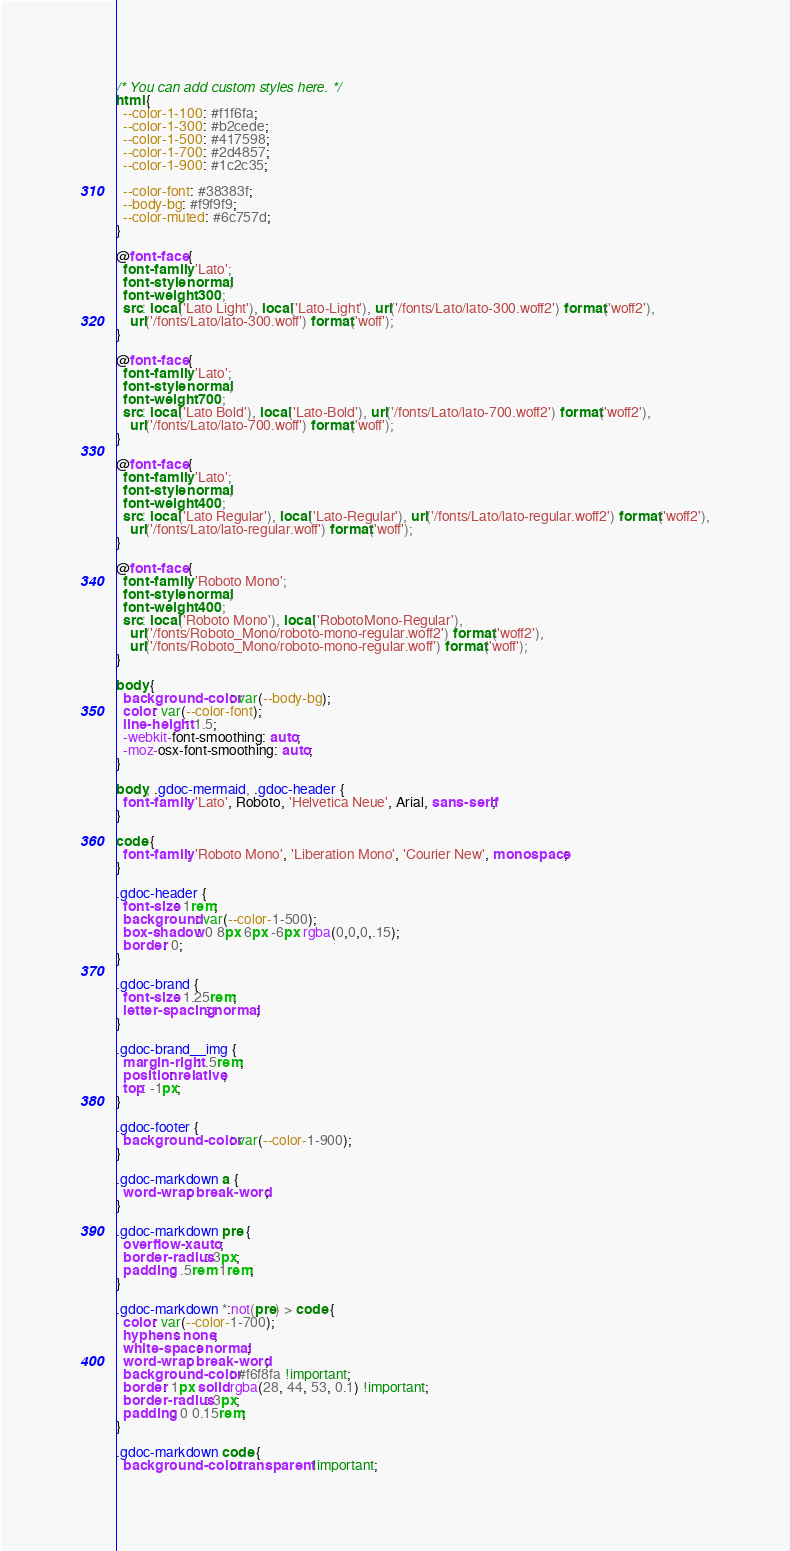Convert code to text. <code><loc_0><loc_0><loc_500><loc_500><_CSS_>/* You can add custom styles here. */
html {
  --color-1-100: #f1f6fa;
  --color-1-300: #b2cede;
  --color-1-500: #417598;
  --color-1-700: #2d4857;
  --color-1-900: #1c2c35;

  --color-font: #38383f;
  --body-bg: #f9f9f9;
  --color-muted: #6c757d;
}

@font-face {
  font-family: 'Lato';
  font-style: normal;
  font-weight: 300;
  src: local('Lato Light'), local('Lato-Light'), url('/fonts/Lato/lato-300.woff2') format('woff2'),
    url('/fonts/Lato/lato-300.woff') format('woff');
}

@font-face {
  font-family: 'Lato';
  font-style: normal;
  font-weight: 700;
  src: local('Lato Bold'), local('Lato-Bold'), url('/fonts/Lato/lato-700.woff2') format('woff2'),
    url('/fonts/Lato/lato-700.woff') format('woff');
}

@font-face {
  font-family: 'Lato';
  font-style: normal;
  font-weight: 400;
  src: local('Lato Regular'), local('Lato-Regular'), url('/fonts/Lato/lato-regular.woff2') format('woff2'),
    url('/fonts/Lato/lato-regular.woff') format('woff');
}

@font-face {
  font-family: 'Roboto Mono';
  font-style: normal;
  font-weight: 400;
  src: local('Roboto Mono'), local('RobotoMono-Regular'),
    url('/fonts/Roboto_Mono/roboto-mono-regular.woff2') format('woff2'),
    url('/fonts/Roboto_Mono/roboto-mono-regular.woff') format('woff');
}

body {
  background-color: var(--body-bg);
  color: var(--color-font);
  line-height: 1.5;
  -webkit-font-smoothing: auto;
  -moz-osx-font-smoothing: auto;
}

body, .gdoc-mermaid, .gdoc-header {
  font-family: 'Lato', Roboto, 'Helvetica Neue', Arial, sans-serif;
}

code {
  font-family: 'Roboto Mono', 'Liberation Mono', 'Courier New', monospace;
}

.gdoc-header {
  font-size: 1rem;
  background: var(--color-1-500);
  box-shadow: 0 8px 6px -6px rgba(0,0,0,.15);
  border: 0;
}

.gdoc-brand {
  font-size: 1.25rem;
  letter-spacing: normal;
}

.gdoc-brand__img {
  margin-right: .5rem;
  position: relative;
  top: -1px;
}

.gdoc-footer {
  background-color: var(--color-1-900);
}

.gdoc-markdown a {
  word-wrap: break-word;
}

.gdoc-markdown pre {
  overflow-x: auto;
  border-radius: 3px;
  padding: .5rem 1rem;
}

.gdoc-markdown *:not(pre) > code {
  color: var(--color-1-700);
  hyphens: none;
  white-space: normal;
  word-wrap: break-word;
  background-color: #f6f8fa !important;
  border: 1px solid rgba(28, 44, 53, 0.1) !important;
  border-radius: 3px;
  padding: 0 0.15rem;
}

.gdoc-markdown code {
  background-color: transparent !important;</code> 